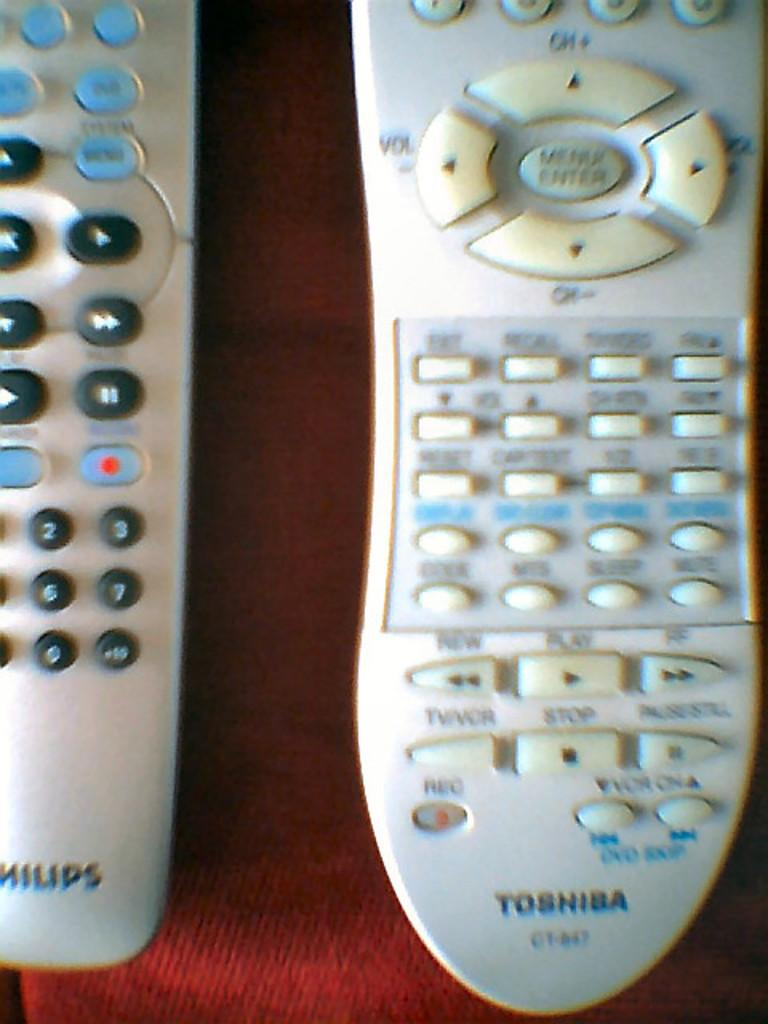<image>
Offer a succinct explanation of the picture presented. Two remote controls and one is for a Phillips device. 